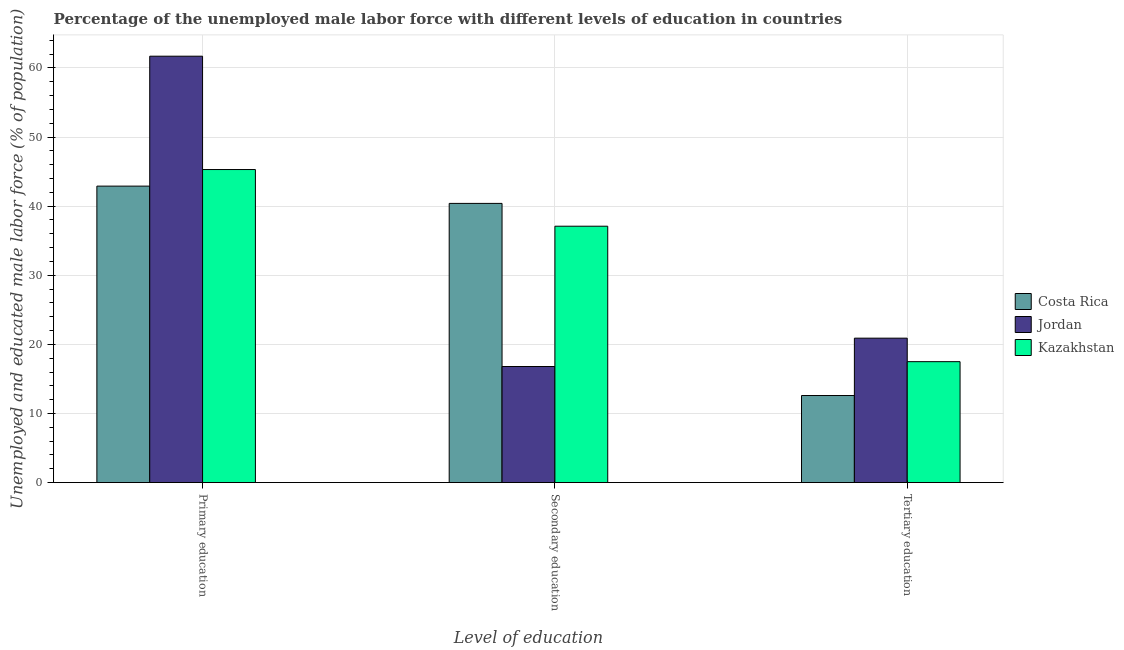How many different coloured bars are there?
Ensure brevity in your answer.  3. How many groups of bars are there?
Offer a very short reply. 3. Are the number of bars per tick equal to the number of legend labels?
Give a very brief answer. Yes. How many bars are there on the 1st tick from the right?
Your response must be concise. 3. What is the percentage of male labor force who received secondary education in Jordan?
Provide a succinct answer. 16.8. Across all countries, what is the maximum percentage of male labor force who received primary education?
Offer a terse response. 61.7. Across all countries, what is the minimum percentage of male labor force who received primary education?
Ensure brevity in your answer.  42.9. In which country was the percentage of male labor force who received tertiary education maximum?
Provide a short and direct response. Jordan. In which country was the percentage of male labor force who received tertiary education minimum?
Provide a succinct answer. Costa Rica. What is the total percentage of male labor force who received secondary education in the graph?
Your response must be concise. 94.3. What is the difference between the percentage of male labor force who received primary education in Jordan and that in Costa Rica?
Keep it short and to the point. 18.8. What is the difference between the percentage of male labor force who received tertiary education in Jordan and the percentage of male labor force who received secondary education in Costa Rica?
Keep it short and to the point. -19.5. What is the average percentage of male labor force who received secondary education per country?
Provide a succinct answer. 31.43. What is the difference between the percentage of male labor force who received secondary education and percentage of male labor force who received tertiary education in Jordan?
Offer a very short reply. -4.1. In how many countries, is the percentage of male labor force who received tertiary education greater than 38 %?
Offer a very short reply. 0. What is the ratio of the percentage of male labor force who received primary education in Costa Rica to that in Kazakhstan?
Keep it short and to the point. 0.95. Is the percentage of male labor force who received secondary education in Costa Rica less than that in Jordan?
Keep it short and to the point. No. What is the difference between the highest and the second highest percentage of male labor force who received tertiary education?
Offer a very short reply. 3.4. What is the difference between the highest and the lowest percentage of male labor force who received tertiary education?
Give a very brief answer. 8.3. In how many countries, is the percentage of male labor force who received secondary education greater than the average percentage of male labor force who received secondary education taken over all countries?
Offer a very short reply. 2. What does the 1st bar from the left in Secondary education represents?
Provide a short and direct response. Costa Rica. How many bars are there?
Keep it short and to the point. 9. Are all the bars in the graph horizontal?
Ensure brevity in your answer.  No. How many countries are there in the graph?
Keep it short and to the point. 3. What is the difference between two consecutive major ticks on the Y-axis?
Provide a succinct answer. 10. Does the graph contain grids?
Provide a short and direct response. Yes. Where does the legend appear in the graph?
Provide a short and direct response. Center right. How many legend labels are there?
Your response must be concise. 3. How are the legend labels stacked?
Give a very brief answer. Vertical. What is the title of the graph?
Provide a short and direct response. Percentage of the unemployed male labor force with different levels of education in countries. What is the label or title of the X-axis?
Offer a very short reply. Level of education. What is the label or title of the Y-axis?
Your response must be concise. Unemployed and educated male labor force (% of population). What is the Unemployed and educated male labor force (% of population) in Costa Rica in Primary education?
Ensure brevity in your answer.  42.9. What is the Unemployed and educated male labor force (% of population) in Jordan in Primary education?
Your answer should be compact. 61.7. What is the Unemployed and educated male labor force (% of population) in Kazakhstan in Primary education?
Provide a succinct answer. 45.3. What is the Unemployed and educated male labor force (% of population) in Costa Rica in Secondary education?
Provide a succinct answer. 40.4. What is the Unemployed and educated male labor force (% of population) of Jordan in Secondary education?
Provide a succinct answer. 16.8. What is the Unemployed and educated male labor force (% of population) of Kazakhstan in Secondary education?
Make the answer very short. 37.1. What is the Unemployed and educated male labor force (% of population) of Costa Rica in Tertiary education?
Your answer should be very brief. 12.6. What is the Unemployed and educated male labor force (% of population) of Jordan in Tertiary education?
Provide a succinct answer. 20.9. Across all Level of education, what is the maximum Unemployed and educated male labor force (% of population) in Costa Rica?
Keep it short and to the point. 42.9. Across all Level of education, what is the maximum Unemployed and educated male labor force (% of population) of Jordan?
Your answer should be very brief. 61.7. Across all Level of education, what is the maximum Unemployed and educated male labor force (% of population) of Kazakhstan?
Your response must be concise. 45.3. Across all Level of education, what is the minimum Unemployed and educated male labor force (% of population) of Costa Rica?
Offer a terse response. 12.6. Across all Level of education, what is the minimum Unemployed and educated male labor force (% of population) of Jordan?
Offer a terse response. 16.8. Across all Level of education, what is the minimum Unemployed and educated male labor force (% of population) in Kazakhstan?
Provide a succinct answer. 17.5. What is the total Unemployed and educated male labor force (% of population) of Costa Rica in the graph?
Your answer should be compact. 95.9. What is the total Unemployed and educated male labor force (% of population) in Jordan in the graph?
Your response must be concise. 99.4. What is the total Unemployed and educated male labor force (% of population) of Kazakhstan in the graph?
Provide a succinct answer. 99.9. What is the difference between the Unemployed and educated male labor force (% of population) of Costa Rica in Primary education and that in Secondary education?
Your answer should be compact. 2.5. What is the difference between the Unemployed and educated male labor force (% of population) of Jordan in Primary education and that in Secondary education?
Make the answer very short. 44.9. What is the difference between the Unemployed and educated male labor force (% of population) of Costa Rica in Primary education and that in Tertiary education?
Give a very brief answer. 30.3. What is the difference between the Unemployed and educated male labor force (% of population) in Jordan in Primary education and that in Tertiary education?
Make the answer very short. 40.8. What is the difference between the Unemployed and educated male labor force (% of population) in Kazakhstan in Primary education and that in Tertiary education?
Your response must be concise. 27.8. What is the difference between the Unemployed and educated male labor force (% of population) of Costa Rica in Secondary education and that in Tertiary education?
Provide a short and direct response. 27.8. What is the difference between the Unemployed and educated male labor force (% of population) in Jordan in Secondary education and that in Tertiary education?
Your response must be concise. -4.1. What is the difference between the Unemployed and educated male labor force (% of population) of Kazakhstan in Secondary education and that in Tertiary education?
Make the answer very short. 19.6. What is the difference between the Unemployed and educated male labor force (% of population) in Costa Rica in Primary education and the Unemployed and educated male labor force (% of population) in Jordan in Secondary education?
Give a very brief answer. 26.1. What is the difference between the Unemployed and educated male labor force (% of population) in Jordan in Primary education and the Unemployed and educated male labor force (% of population) in Kazakhstan in Secondary education?
Your answer should be very brief. 24.6. What is the difference between the Unemployed and educated male labor force (% of population) of Costa Rica in Primary education and the Unemployed and educated male labor force (% of population) of Jordan in Tertiary education?
Keep it short and to the point. 22. What is the difference between the Unemployed and educated male labor force (% of population) of Costa Rica in Primary education and the Unemployed and educated male labor force (% of population) of Kazakhstan in Tertiary education?
Your answer should be very brief. 25.4. What is the difference between the Unemployed and educated male labor force (% of population) of Jordan in Primary education and the Unemployed and educated male labor force (% of population) of Kazakhstan in Tertiary education?
Make the answer very short. 44.2. What is the difference between the Unemployed and educated male labor force (% of population) of Costa Rica in Secondary education and the Unemployed and educated male labor force (% of population) of Jordan in Tertiary education?
Your answer should be very brief. 19.5. What is the difference between the Unemployed and educated male labor force (% of population) of Costa Rica in Secondary education and the Unemployed and educated male labor force (% of population) of Kazakhstan in Tertiary education?
Give a very brief answer. 22.9. What is the average Unemployed and educated male labor force (% of population) of Costa Rica per Level of education?
Keep it short and to the point. 31.97. What is the average Unemployed and educated male labor force (% of population) of Jordan per Level of education?
Make the answer very short. 33.13. What is the average Unemployed and educated male labor force (% of population) in Kazakhstan per Level of education?
Offer a very short reply. 33.3. What is the difference between the Unemployed and educated male labor force (% of population) in Costa Rica and Unemployed and educated male labor force (% of population) in Jordan in Primary education?
Provide a succinct answer. -18.8. What is the difference between the Unemployed and educated male labor force (% of population) in Jordan and Unemployed and educated male labor force (% of population) in Kazakhstan in Primary education?
Your answer should be compact. 16.4. What is the difference between the Unemployed and educated male labor force (% of population) in Costa Rica and Unemployed and educated male labor force (% of population) in Jordan in Secondary education?
Offer a very short reply. 23.6. What is the difference between the Unemployed and educated male labor force (% of population) in Jordan and Unemployed and educated male labor force (% of population) in Kazakhstan in Secondary education?
Make the answer very short. -20.3. What is the difference between the Unemployed and educated male labor force (% of population) of Costa Rica and Unemployed and educated male labor force (% of population) of Jordan in Tertiary education?
Keep it short and to the point. -8.3. What is the ratio of the Unemployed and educated male labor force (% of population) of Costa Rica in Primary education to that in Secondary education?
Offer a very short reply. 1.06. What is the ratio of the Unemployed and educated male labor force (% of population) in Jordan in Primary education to that in Secondary education?
Offer a very short reply. 3.67. What is the ratio of the Unemployed and educated male labor force (% of population) in Kazakhstan in Primary education to that in Secondary education?
Make the answer very short. 1.22. What is the ratio of the Unemployed and educated male labor force (% of population) of Costa Rica in Primary education to that in Tertiary education?
Your answer should be very brief. 3.4. What is the ratio of the Unemployed and educated male labor force (% of population) of Jordan in Primary education to that in Tertiary education?
Your answer should be compact. 2.95. What is the ratio of the Unemployed and educated male labor force (% of population) in Kazakhstan in Primary education to that in Tertiary education?
Offer a terse response. 2.59. What is the ratio of the Unemployed and educated male labor force (% of population) of Costa Rica in Secondary education to that in Tertiary education?
Your answer should be compact. 3.21. What is the ratio of the Unemployed and educated male labor force (% of population) of Jordan in Secondary education to that in Tertiary education?
Your answer should be compact. 0.8. What is the ratio of the Unemployed and educated male labor force (% of population) of Kazakhstan in Secondary education to that in Tertiary education?
Offer a terse response. 2.12. What is the difference between the highest and the second highest Unemployed and educated male labor force (% of population) in Jordan?
Give a very brief answer. 40.8. What is the difference between the highest and the second highest Unemployed and educated male labor force (% of population) in Kazakhstan?
Offer a terse response. 8.2. What is the difference between the highest and the lowest Unemployed and educated male labor force (% of population) in Costa Rica?
Keep it short and to the point. 30.3. What is the difference between the highest and the lowest Unemployed and educated male labor force (% of population) of Jordan?
Keep it short and to the point. 44.9. What is the difference between the highest and the lowest Unemployed and educated male labor force (% of population) of Kazakhstan?
Provide a succinct answer. 27.8. 